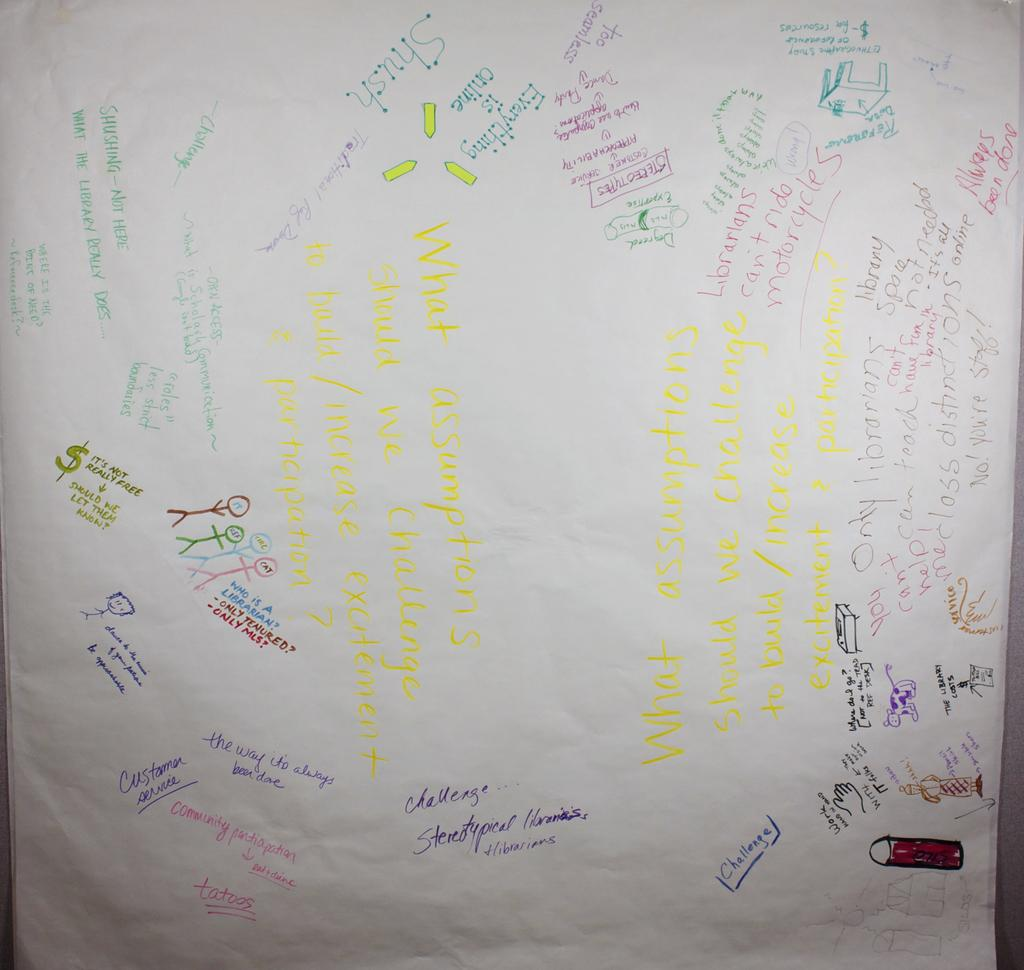<image>
Offer a succinct explanation of the picture presented. A large piece of paper with lots of multicolored writing on it, so of which says It's not really free. 